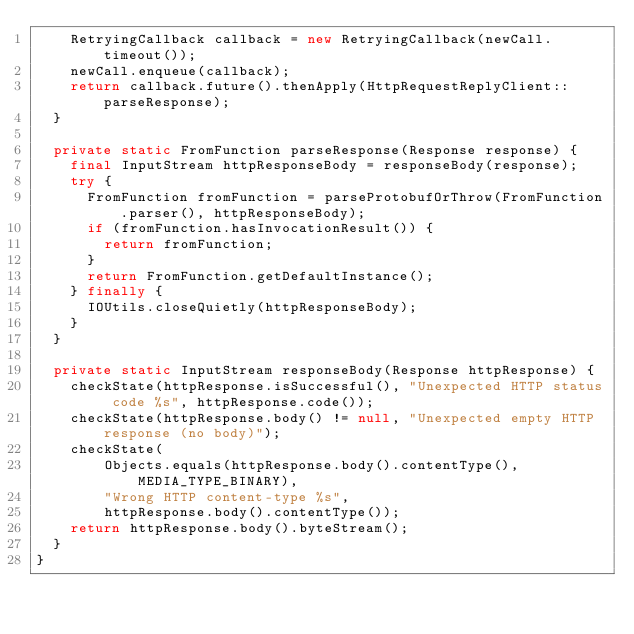<code> <loc_0><loc_0><loc_500><loc_500><_Java_>    RetryingCallback callback = new RetryingCallback(newCall.timeout());
    newCall.enqueue(callback);
    return callback.future().thenApply(HttpRequestReplyClient::parseResponse);
  }

  private static FromFunction parseResponse(Response response) {
    final InputStream httpResponseBody = responseBody(response);
    try {
      FromFunction fromFunction = parseProtobufOrThrow(FromFunction.parser(), httpResponseBody);
      if (fromFunction.hasInvocationResult()) {
        return fromFunction;
      }
      return FromFunction.getDefaultInstance();
    } finally {
      IOUtils.closeQuietly(httpResponseBody);
    }
  }

  private static InputStream responseBody(Response httpResponse) {
    checkState(httpResponse.isSuccessful(), "Unexpected HTTP status code %s", httpResponse.code());
    checkState(httpResponse.body() != null, "Unexpected empty HTTP response (no body)");
    checkState(
        Objects.equals(httpResponse.body().contentType(), MEDIA_TYPE_BINARY),
        "Wrong HTTP content-type %s",
        httpResponse.body().contentType());
    return httpResponse.body().byteStream();
  }
}
</code> 